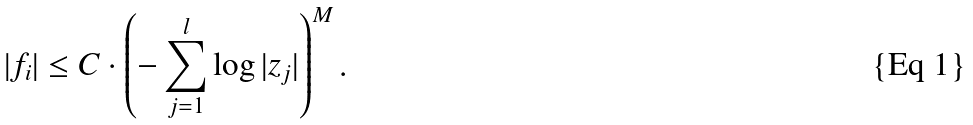Convert formula to latex. <formula><loc_0><loc_0><loc_500><loc_500>| f _ { i } | \leq C \cdot \left ( - \sum _ { j = 1 } ^ { l } \log | z _ { j } | \right ) ^ { M } .</formula> 